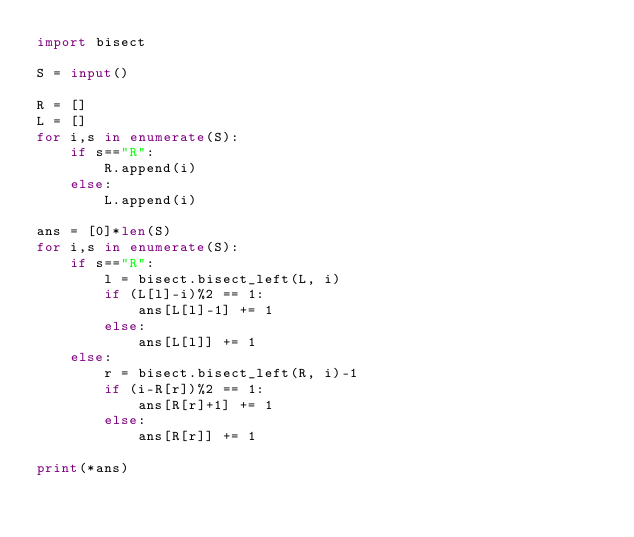Convert code to text. <code><loc_0><loc_0><loc_500><loc_500><_Python_>import bisect

S = input()

R = []
L = []
for i,s in enumerate(S):
    if s=="R":
        R.append(i)
    else:
        L.append(i)

ans = [0]*len(S)    
for i,s in enumerate(S):
    if s=="R":
        l = bisect.bisect_left(L, i)
        if (L[l]-i)%2 == 1:
            ans[L[l]-1] += 1
        else:
            ans[L[l]] += 1
    else:
        r = bisect.bisect_left(R, i)-1
        if (i-R[r])%2 == 1:
            ans[R[r]+1] += 1
        else:
            ans[R[r]] += 1
            
print(*ans)</code> 